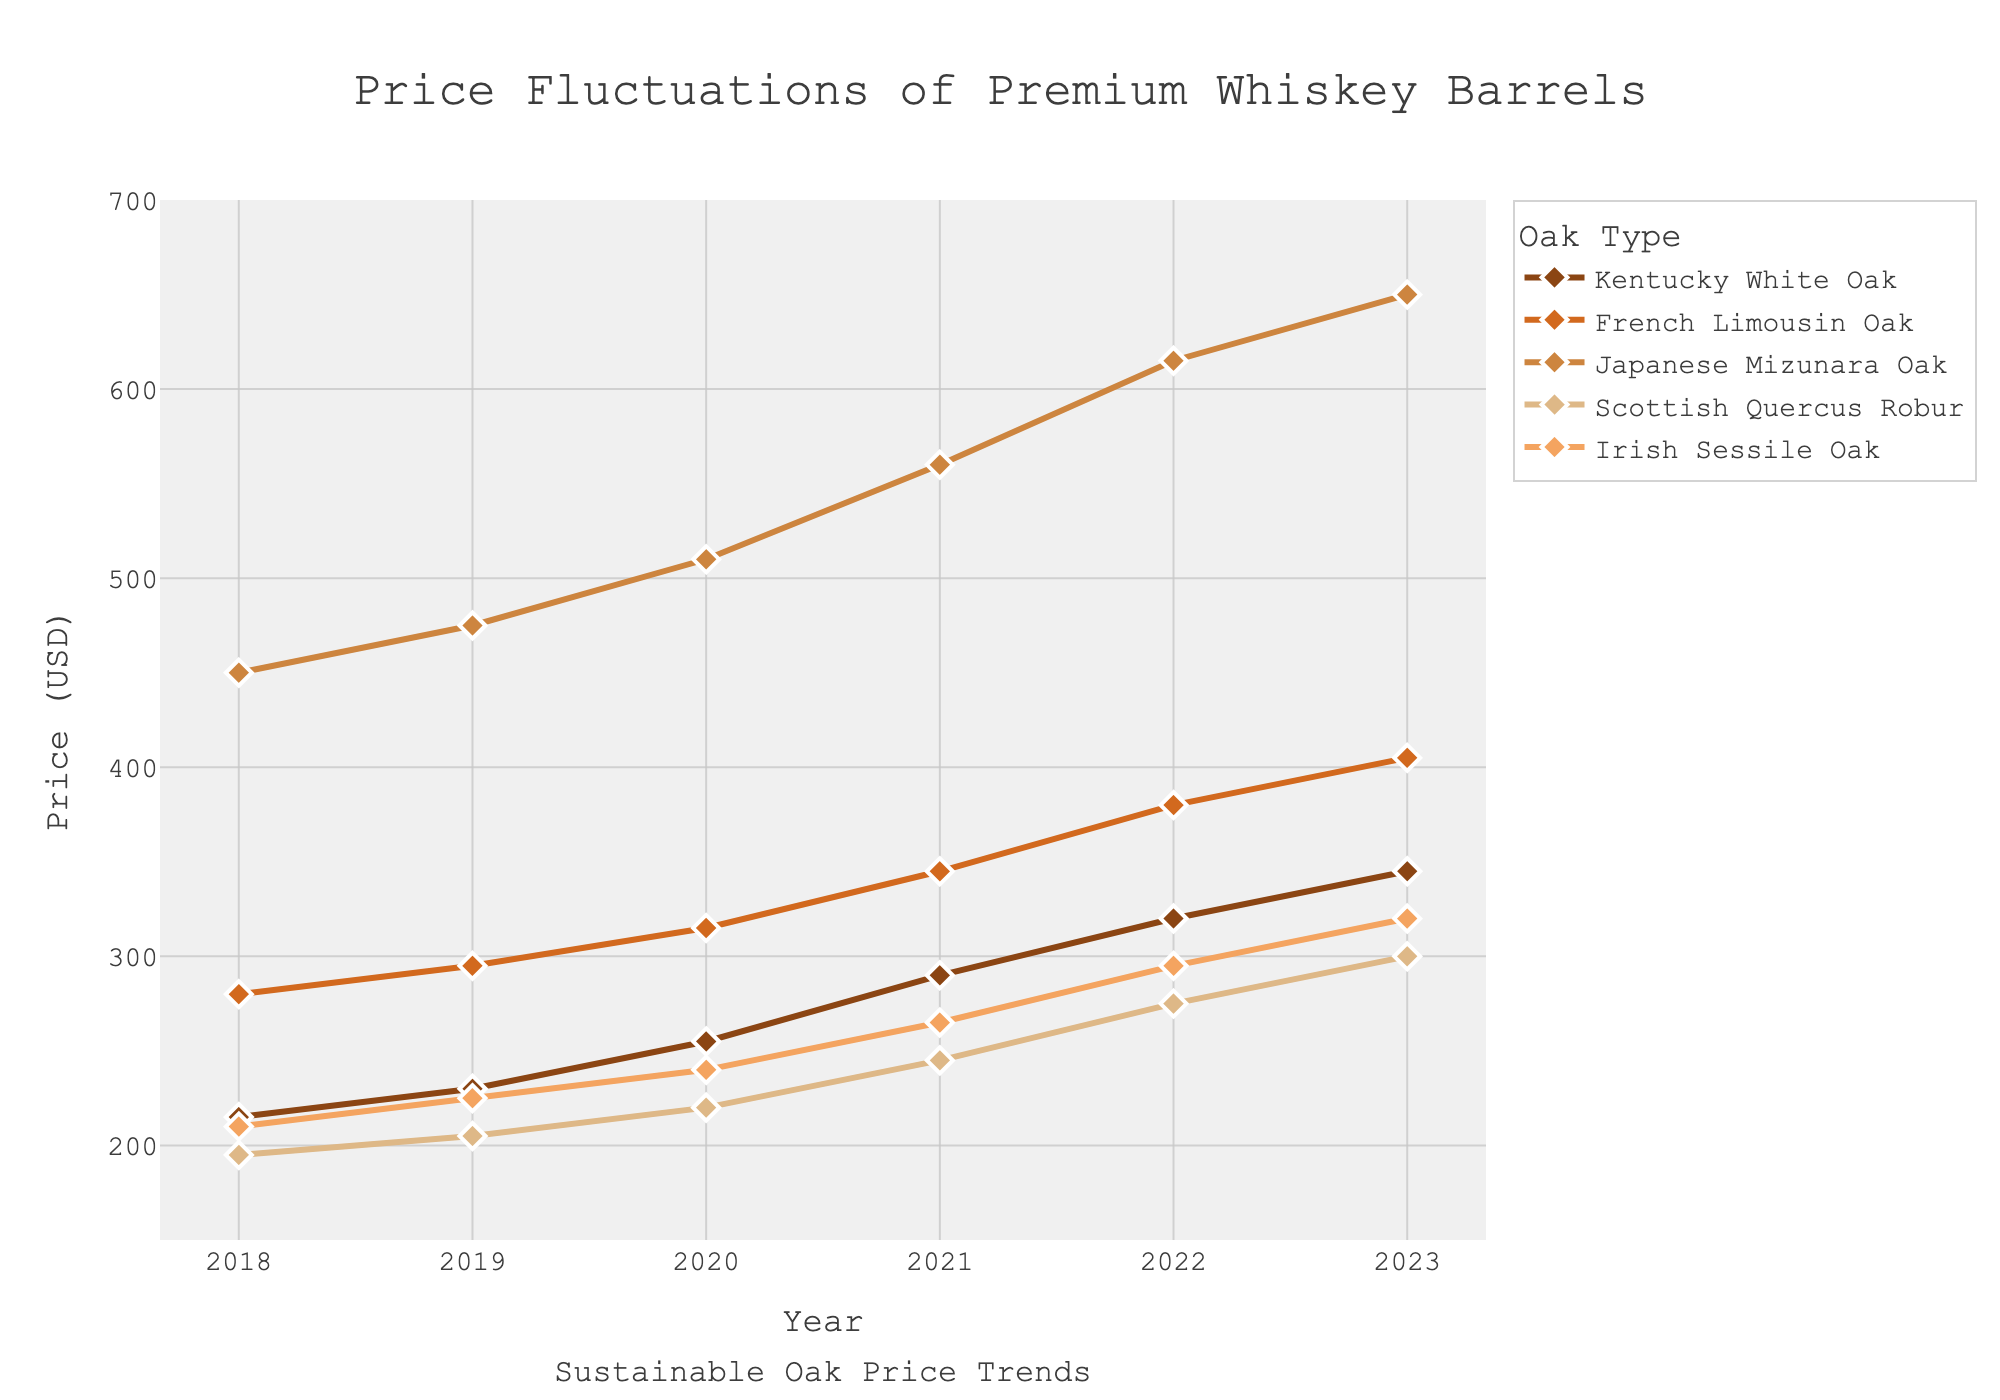What is the price increase for Kentucky White Oak barrels from 2018 to 2023? To find the price increase, subtract the price in 2018 (215) from the price in 2023 (345). The calculation is 345 - 215.
Answer: 130 USD Which oak type had the highest price in 2023? Looking at the prices in 2023 for all oak types, Japanese Mizunara Oak has the highest price at 650 USD.
Answer: Japanese Mizunara Oak Which two oak types had the smallest price difference in 2021? To find this, compute the absolute price differences among all pairs in 2021. Kentucky White Oak and Irish Sessile Oak have prices of 290 and 265, respectively. Their difference is
Answer: 25 USD Which oak type has the steepest increase in price from 2018 to 2023? The steepest increase corresponds to the highest price increase over the years. The price increase for each oak type is: Kentucky White Oak (130), French Limousin Oak (125), Japanese Mizunara Oak (200), Scottish Quercus Robur (105), and Irish Sessile Oak (110). Japanese Mizunara Oak has the steepest increase.
Answer: Japanese Mizunara Oak What was the average price of barrels across all oak types in 2020? Calculate the mean price for all oak types in 2020. Sum of prices in 2020 is 255 (K) + 315 (F) + 510 (J) + 220 (S) + 240 (I) = 1540. Average is 1540 / 5.
Answer: 308 USD Which oak type had a price greater than 500 USD in 2021? Looking at the prices in 2021, the only oak type over 500 USD is Japanese Mizunara Oak with a price of 560 USD.
Answer: Japanese Mizunara Oak What is the trend in prices for Scottish Quercus Robur barrels from 2018 to 2023? Observing the prices for Scottish Quercus Robur from 2018 to 2023, we see a consistent increase: 195, 205, 220, 245, 275, and 300.
Answer: Increasing How does the price of French Limousin Oak compare to Irish Sessile Oak in 2022? Compare their prices in 2022: French Limousin Oak is 380 USD, and Irish Sessile Oak is 295 USD. 380 is greater than 295.
Answer: French Limousin Oak is more expensive What is the cumulative price increase for Japanese Mizunara Oak from 2018 to 2023? Cumulative increase is computed as the final price minus the initial price: 650 - 450.
Answer: 200 USD Which oak types experienced a price increase of at least 100 USD from 2018 to 2023? Calculate the price increase for each oak type over the period. Kentucky White Oak (130), French Limousin Oak (125), Japanese Mizunara Oak (200), Scottish Quercus Robur (105), and Irish Sessile Oak (110). Every oak type listed experienced an increase of at least 100 USD.
Answer: All types 